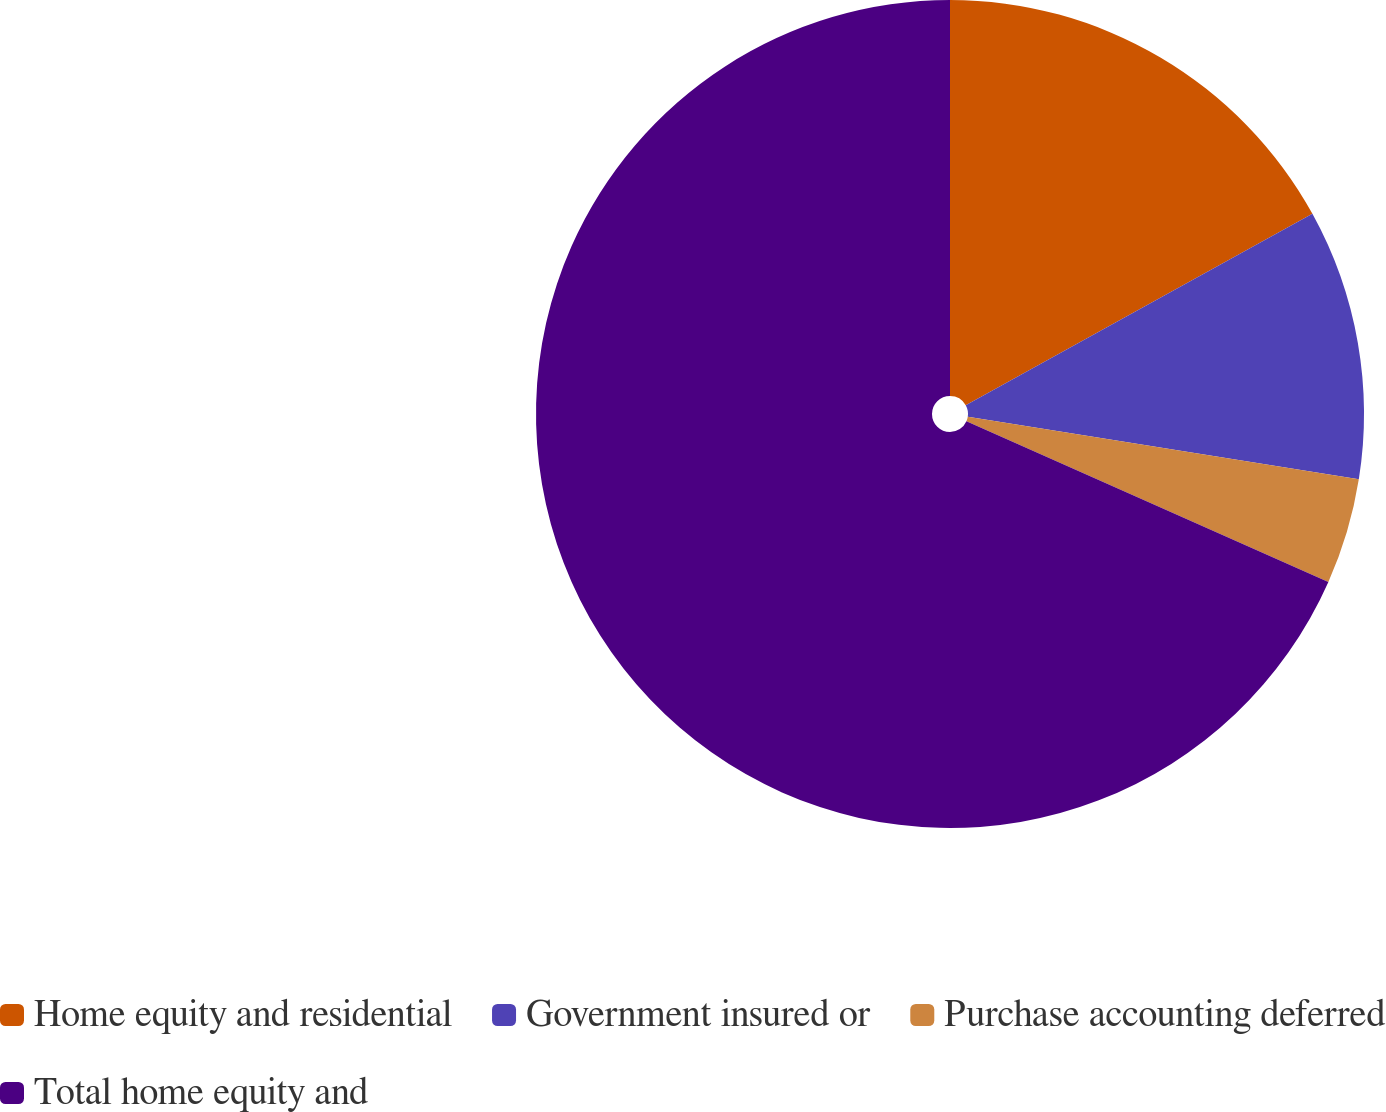Convert chart to OTSL. <chart><loc_0><loc_0><loc_500><loc_500><pie_chart><fcel>Home equity and residential<fcel>Government insured or<fcel>Purchase accounting deferred<fcel>Total home equity and<nl><fcel>16.97%<fcel>10.55%<fcel>4.13%<fcel>68.35%<nl></chart> 